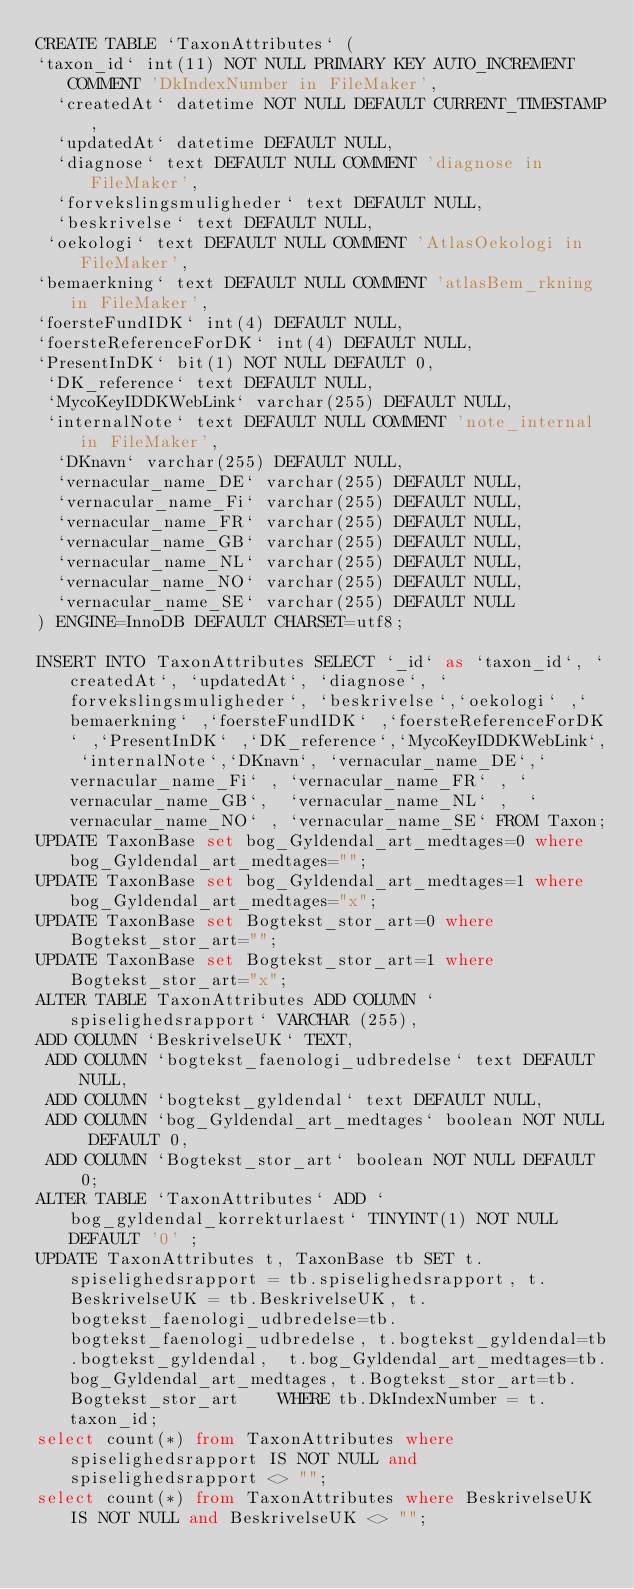<code> <loc_0><loc_0><loc_500><loc_500><_SQL_>CREATE TABLE `TaxonAttributes` (
`taxon_id` int(11) NOT NULL PRIMARY KEY AUTO_INCREMENT COMMENT 'DkIndexNumber in FileMaker',
  `createdAt` datetime NOT NULL DEFAULT CURRENT_TIMESTAMP,
  `updatedAt` datetime DEFAULT NULL,
  `diagnose` text DEFAULT NULL COMMENT 'diagnose in FileMaker',
  `forvekslingsmuligheder` text DEFAULT NULL,
  `beskrivelse` text DEFAULT NULL,
 `oekologi` text DEFAULT NULL COMMENT 'AtlasOekologi in FileMaker',
`bemaerkning` text DEFAULT NULL COMMENT 'atlasBem_rkning in FileMaker',
`foersteFundIDK` int(4) DEFAULT NULL,
`foersteReferenceForDK` int(4) DEFAULT NULL,
`PresentInDK` bit(1) NOT NULL DEFAULT 0,
 `DK_reference` text DEFAULT NULL,
 `MycoKeyIDDKWebLink` varchar(255) DEFAULT NULL,
 `internalNote` text DEFAULT NULL COMMENT 'note_internal in FileMaker',
  `DKnavn` varchar(255) DEFAULT NULL,
  `vernacular_name_DE` varchar(255) DEFAULT NULL,
  `vernacular_name_Fi` varchar(255) DEFAULT NULL,
  `vernacular_name_FR` varchar(255) DEFAULT NULL,
  `vernacular_name_GB` varchar(255) DEFAULT NULL,
  `vernacular_name_NL` varchar(255) DEFAULT NULL,
  `vernacular_name_NO` varchar(255) DEFAULT NULL,
  `vernacular_name_SE` varchar(255) DEFAULT NULL
) ENGINE=InnoDB DEFAULT CHARSET=utf8;

INSERT INTO TaxonAttributes SELECT `_id` as `taxon_id`, `createdAt`, `updatedAt`, `diagnose`, `forvekslingsmuligheder`, `beskrivelse`,`oekologi` ,`bemaerkning` ,`foersteFundIDK` ,`foersteReferenceForDK` ,`PresentInDK` ,`DK_reference`,`MycoKeyIDDKWebLink`, `internalNote`,`DKnavn`, `vernacular_name_DE`,`vernacular_name_Fi` , `vernacular_name_FR` , `vernacular_name_GB`,  `vernacular_name_NL` ,  `vernacular_name_NO` , `vernacular_name_SE` FROM Taxon;
UPDATE TaxonBase set bog_Gyldendal_art_medtages=0 where bog_Gyldendal_art_medtages="";
UPDATE TaxonBase set bog_Gyldendal_art_medtages=1 where bog_Gyldendal_art_medtages="x";
UPDATE TaxonBase set Bogtekst_stor_art=0 where Bogtekst_stor_art="";
UPDATE TaxonBase set Bogtekst_stor_art=1 where Bogtekst_stor_art="x";
ALTER TABLE TaxonAttributes ADD COLUMN `spiselighedsrapport` VARCHAR (255), 
ADD COLUMN `BeskrivelseUK` TEXT,
 ADD COLUMN `bogtekst_faenologi_udbredelse` text DEFAULT NULL,
 ADD COLUMN `bogtekst_gyldendal` text DEFAULT NULL,
 ADD COLUMN `bog_Gyldendal_art_medtages` boolean NOT NULL DEFAULT 0,
 ADD COLUMN `Bogtekst_stor_art` boolean NOT NULL DEFAULT 0;
ALTER TABLE `TaxonAttributes` ADD `bog_gyldendal_korrekturlaest` TINYINT(1) NOT NULL DEFAULT '0' ;
UPDATE TaxonAttributes t, TaxonBase tb SET t.spiselighedsrapport = tb.spiselighedsrapport, t.BeskrivelseUK = tb.BeskrivelseUK, t.bogtekst_faenologi_udbredelse=tb.bogtekst_faenologi_udbredelse, t.bogtekst_gyldendal=tb.bogtekst_gyldendal,  t.bog_Gyldendal_art_medtages=tb.bog_Gyldendal_art_medtages, t.Bogtekst_stor_art=tb.Bogtekst_stor_art    WHERE tb.DkIndexNumber = t.taxon_id;
select count(*) from TaxonAttributes where spiselighedsrapport IS NOT NULL and spiselighedsrapport <> "";
select count(*) from TaxonAttributes where BeskrivelseUK IS NOT NULL and BeskrivelseUK <> "";</code> 